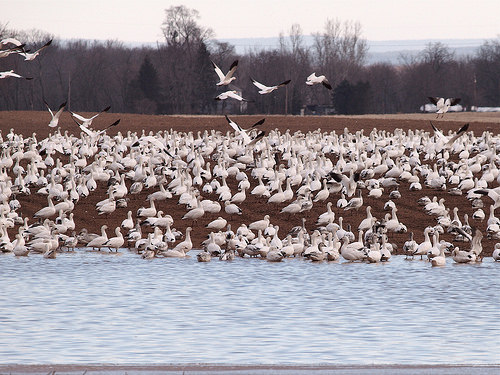<image>
Is there a bird in the water? No. The bird is not contained within the water. These objects have a different spatial relationship. 